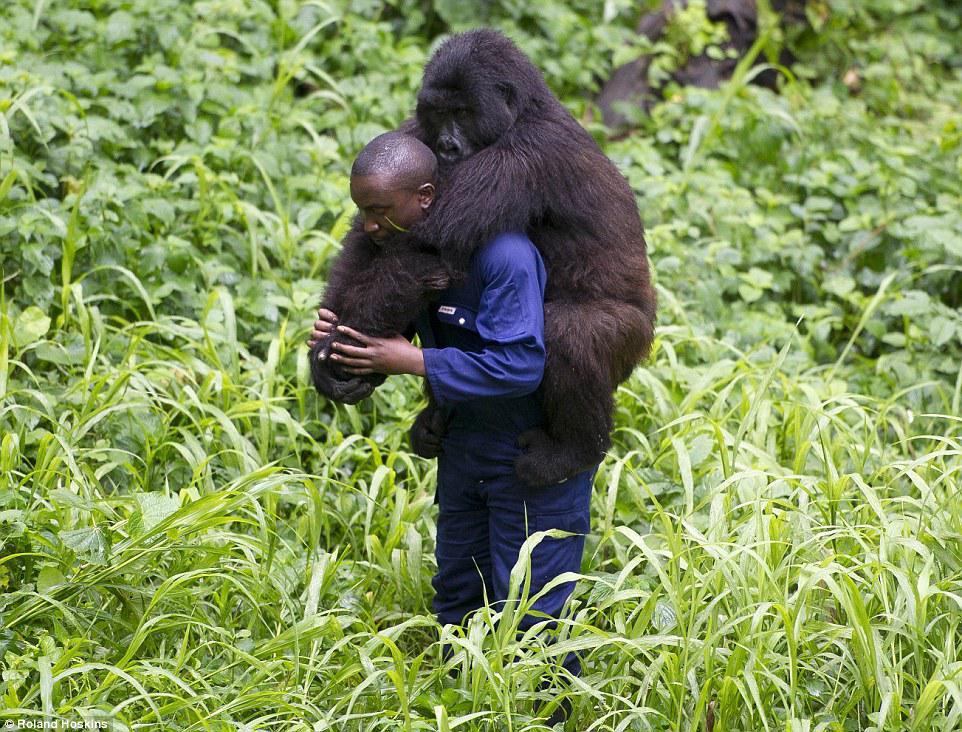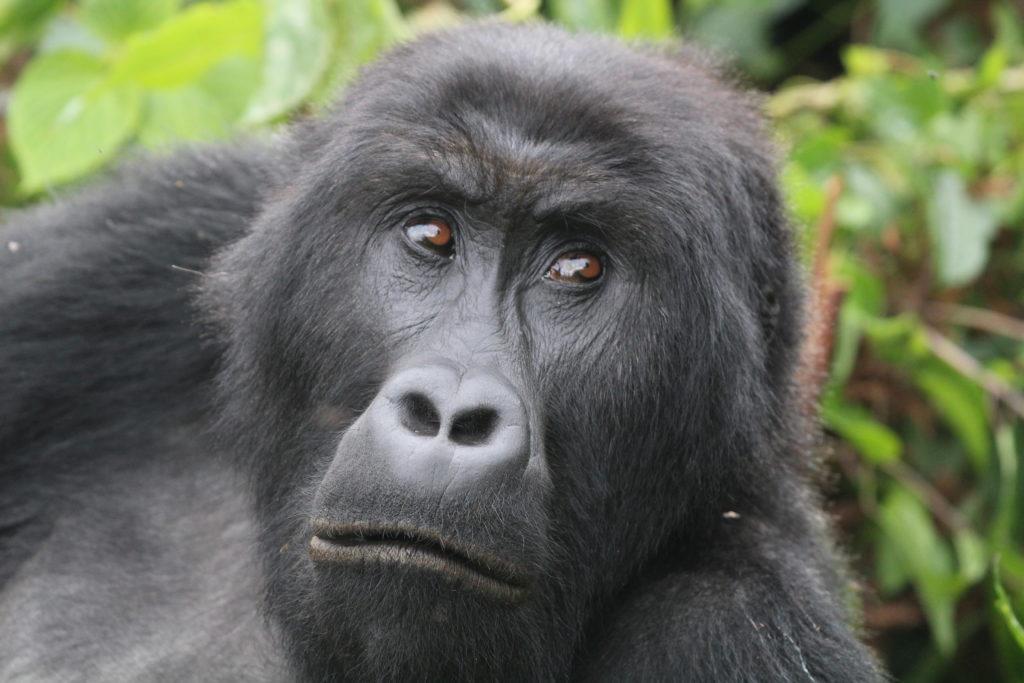The first image is the image on the left, the second image is the image on the right. Given the left and right images, does the statement "An image shows one man in a scene with a dark-haired ape." hold true? Answer yes or no. Yes. The first image is the image on the left, the second image is the image on the right. Analyze the images presented: Is the assertion "Each gorilla is standing on at least two legs." valid? Answer yes or no. No. 